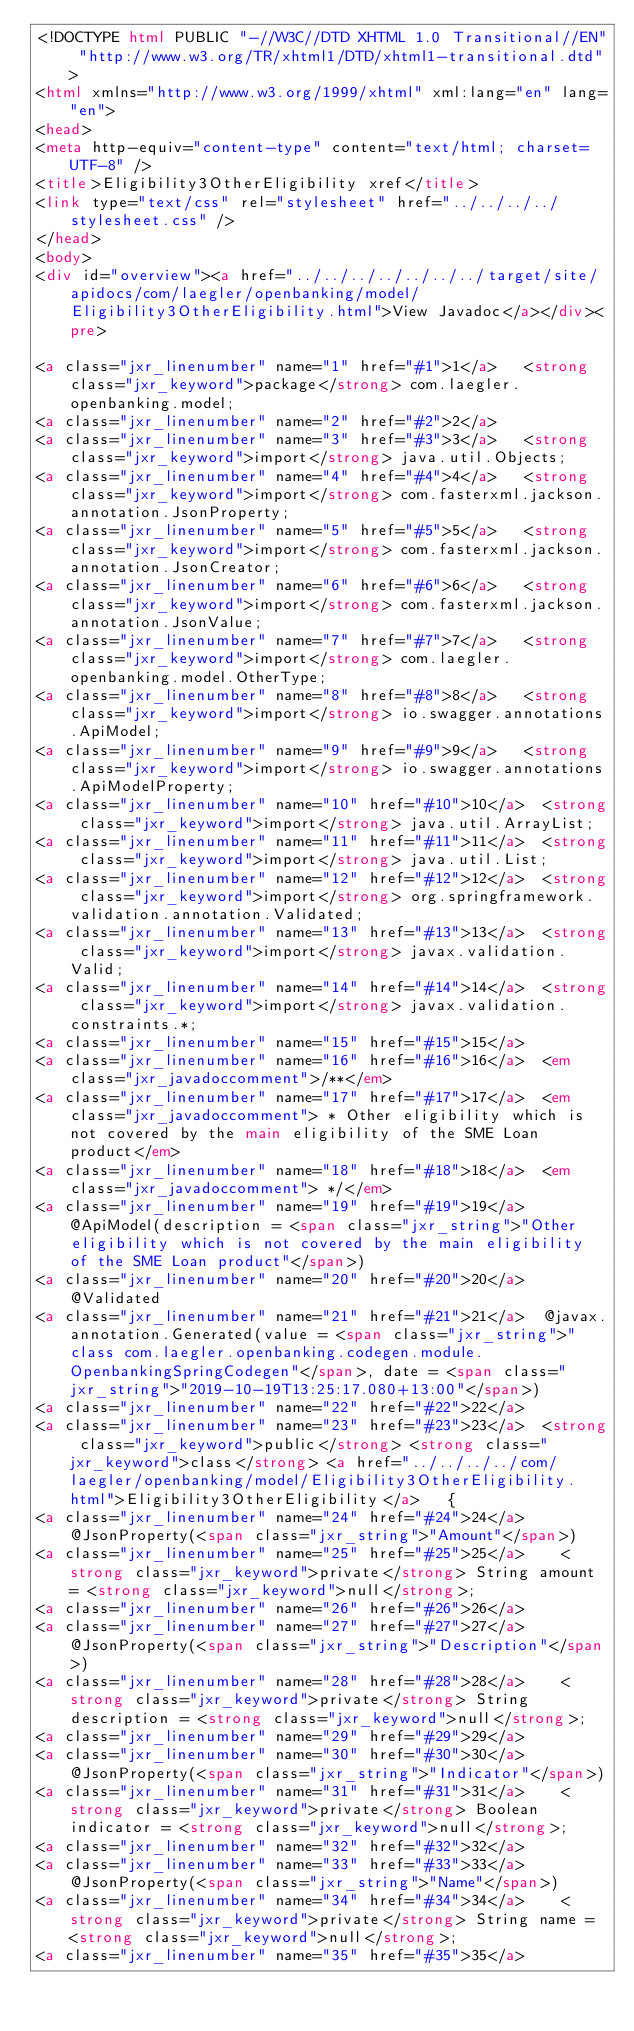<code> <loc_0><loc_0><loc_500><loc_500><_HTML_><!DOCTYPE html PUBLIC "-//W3C//DTD XHTML 1.0 Transitional//EN" "http://www.w3.org/TR/xhtml1/DTD/xhtml1-transitional.dtd">
<html xmlns="http://www.w3.org/1999/xhtml" xml:lang="en" lang="en">
<head>
<meta http-equiv="content-type" content="text/html; charset=UTF-8" />
<title>Eligibility3OtherEligibility xref</title>
<link type="text/css" rel="stylesheet" href="../../../../stylesheet.css" />
</head>
<body>
<div id="overview"><a href="../../../../../../../target/site/apidocs/com/laegler/openbanking/model/Eligibility3OtherEligibility.html">View Javadoc</a></div><pre>

<a class="jxr_linenumber" name="1" href="#1">1</a>   <strong class="jxr_keyword">package</strong> com.laegler.openbanking.model;
<a class="jxr_linenumber" name="2" href="#2">2</a>   
<a class="jxr_linenumber" name="3" href="#3">3</a>   <strong class="jxr_keyword">import</strong> java.util.Objects;
<a class="jxr_linenumber" name="4" href="#4">4</a>   <strong class="jxr_keyword">import</strong> com.fasterxml.jackson.annotation.JsonProperty;
<a class="jxr_linenumber" name="5" href="#5">5</a>   <strong class="jxr_keyword">import</strong> com.fasterxml.jackson.annotation.JsonCreator;
<a class="jxr_linenumber" name="6" href="#6">6</a>   <strong class="jxr_keyword">import</strong> com.fasterxml.jackson.annotation.JsonValue;
<a class="jxr_linenumber" name="7" href="#7">7</a>   <strong class="jxr_keyword">import</strong> com.laegler.openbanking.model.OtherType;
<a class="jxr_linenumber" name="8" href="#8">8</a>   <strong class="jxr_keyword">import</strong> io.swagger.annotations.ApiModel;
<a class="jxr_linenumber" name="9" href="#9">9</a>   <strong class="jxr_keyword">import</strong> io.swagger.annotations.ApiModelProperty;
<a class="jxr_linenumber" name="10" href="#10">10</a>  <strong class="jxr_keyword">import</strong> java.util.ArrayList;
<a class="jxr_linenumber" name="11" href="#11">11</a>  <strong class="jxr_keyword">import</strong> java.util.List;
<a class="jxr_linenumber" name="12" href="#12">12</a>  <strong class="jxr_keyword">import</strong> org.springframework.validation.annotation.Validated;
<a class="jxr_linenumber" name="13" href="#13">13</a>  <strong class="jxr_keyword">import</strong> javax.validation.Valid;
<a class="jxr_linenumber" name="14" href="#14">14</a>  <strong class="jxr_keyword">import</strong> javax.validation.constraints.*;
<a class="jxr_linenumber" name="15" href="#15">15</a>  
<a class="jxr_linenumber" name="16" href="#16">16</a>  <em class="jxr_javadoccomment">/**</em>
<a class="jxr_linenumber" name="17" href="#17">17</a>  <em class="jxr_javadoccomment"> * Other eligibility which is not covered by the main eligibility of the SME Loan product</em>
<a class="jxr_linenumber" name="18" href="#18">18</a>  <em class="jxr_javadoccomment"> */</em>
<a class="jxr_linenumber" name="19" href="#19">19</a>  @ApiModel(description = <span class="jxr_string">"Other eligibility which is not covered by the main eligibility of the SME Loan product"</span>)
<a class="jxr_linenumber" name="20" href="#20">20</a>  @Validated
<a class="jxr_linenumber" name="21" href="#21">21</a>  @javax.annotation.Generated(value = <span class="jxr_string">"class com.laegler.openbanking.codegen.module.OpenbankingSpringCodegen"</span>, date = <span class="jxr_string">"2019-10-19T13:25:17.080+13:00"</span>)
<a class="jxr_linenumber" name="22" href="#22">22</a>  
<a class="jxr_linenumber" name="23" href="#23">23</a>  <strong class="jxr_keyword">public</strong> <strong class="jxr_keyword">class</strong> <a href="../../../../com/laegler/openbanking/model/Eligibility3OtherEligibility.html">Eligibility3OtherEligibility</a>   {
<a class="jxr_linenumber" name="24" href="#24">24</a>    @JsonProperty(<span class="jxr_string">"Amount"</span>)
<a class="jxr_linenumber" name="25" href="#25">25</a>    <strong class="jxr_keyword">private</strong> String amount = <strong class="jxr_keyword">null</strong>;
<a class="jxr_linenumber" name="26" href="#26">26</a>  
<a class="jxr_linenumber" name="27" href="#27">27</a>    @JsonProperty(<span class="jxr_string">"Description"</span>)
<a class="jxr_linenumber" name="28" href="#28">28</a>    <strong class="jxr_keyword">private</strong> String description = <strong class="jxr_keyword">null</strong>;
<a class="jxr_linenumber" name="29" href="#29">29</a>  
<a class="jxr_linenumber" name="30" href="#30">30</a>    @JsonProperty(<span class="jxr_string">"Indicator"</span>)
<a class="jxr_linenumber" name="31" href="#31">31</a>    <strong class="jxr_keyword">private</strong> Boolean indicator = <strong class="jxr_keyword">null</strong>;
<a class="jxr_linenumber" name="32" href="#32">32</a>  
<a class="jxr_linenumber" name="33" href="#33">33</a>    @JsonProperty(<span class="jxr_string">"Name"</span>)
<a class="jxr_linenumber" name="34" href="#34">34</a>    <strong class="jxr_keyword">private</strong> String name = <strong class="jxr_keyword">null</strong>;
<a class="jxr_linenumber" name="35" href="#35">35</a>  </code> 